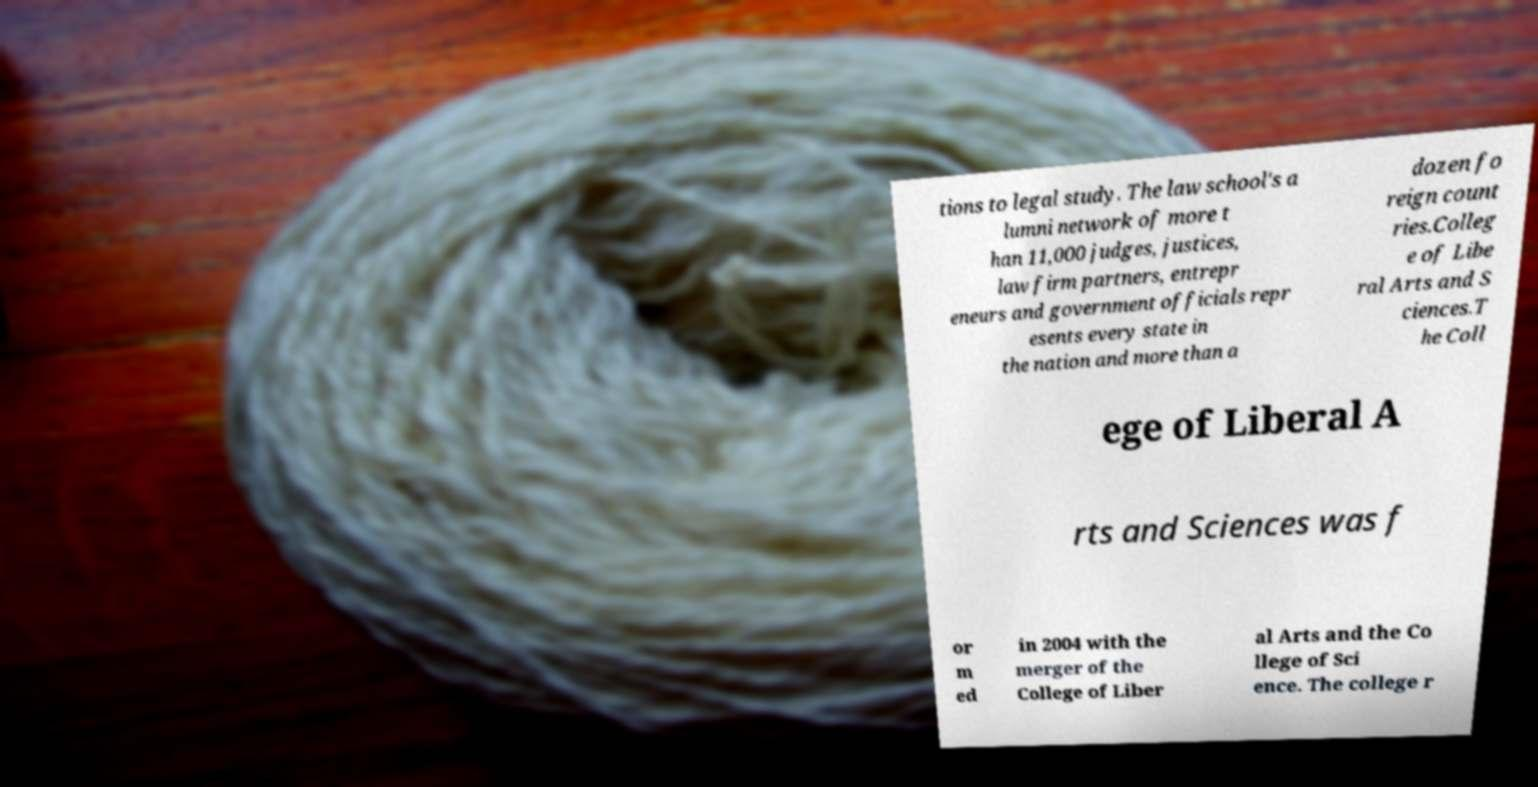There's text embedded in this image that I need extracted. Can you transcribe it verbatim? tions to legal study. The law school's a lumni network of more t han 11,000 judges, justices, law firm partners, entrepr eneurs and government officials repr esents every state in the nation and more than a dozen fo reign count ries.Colleg e of Libe ral Arts and S ciences.T he Coll ege of Liberal A rts and Sciences was f or m ed in 2004 with the merger of the College of Liber al Arts and the Co llege of Sci ence. The college r 